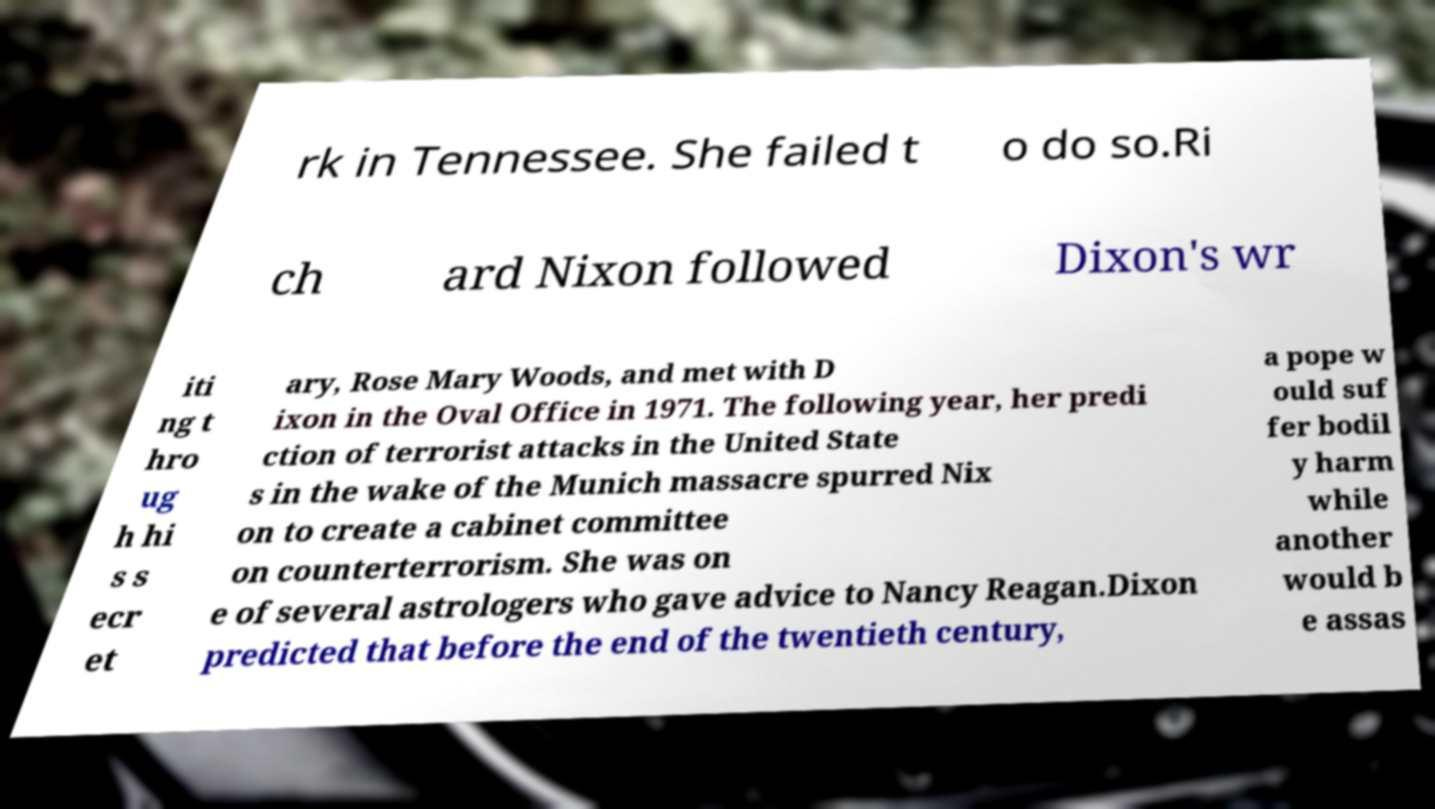Can you read and provide the text displayed in the image?This photo seems to have some interesting text. Can you extract and type it out for me? rk in Tennessee. She failed t o do so.Ri ch ard Nixon followed Dixon's wr iti ng t hro ug h hi s s ecr et ary, Rose Mary Woods, and met with D ixon in the Oval Office in 1971. The following year, her predi ction of terrorist attacks in the United State s in the wake of the Munich massacre spurred Nix on to create a cabinet committee on counterterrorism. She was on e of several astrologers who gave advice to Nancy Reagan.Dixon predicted that before the end of the twentieth century, a pope w ould suf fer bodil y harm while another would b e assas 